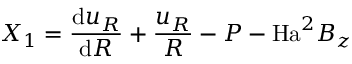<formula> <loc_0><loc_0><loc_500><loc_500>X _ { 1 } = \frac { d u _ { R } } { d R } + \frac { u _ { R } } { R } - P - H a ^ { 2 } B _ { z }</formula> 